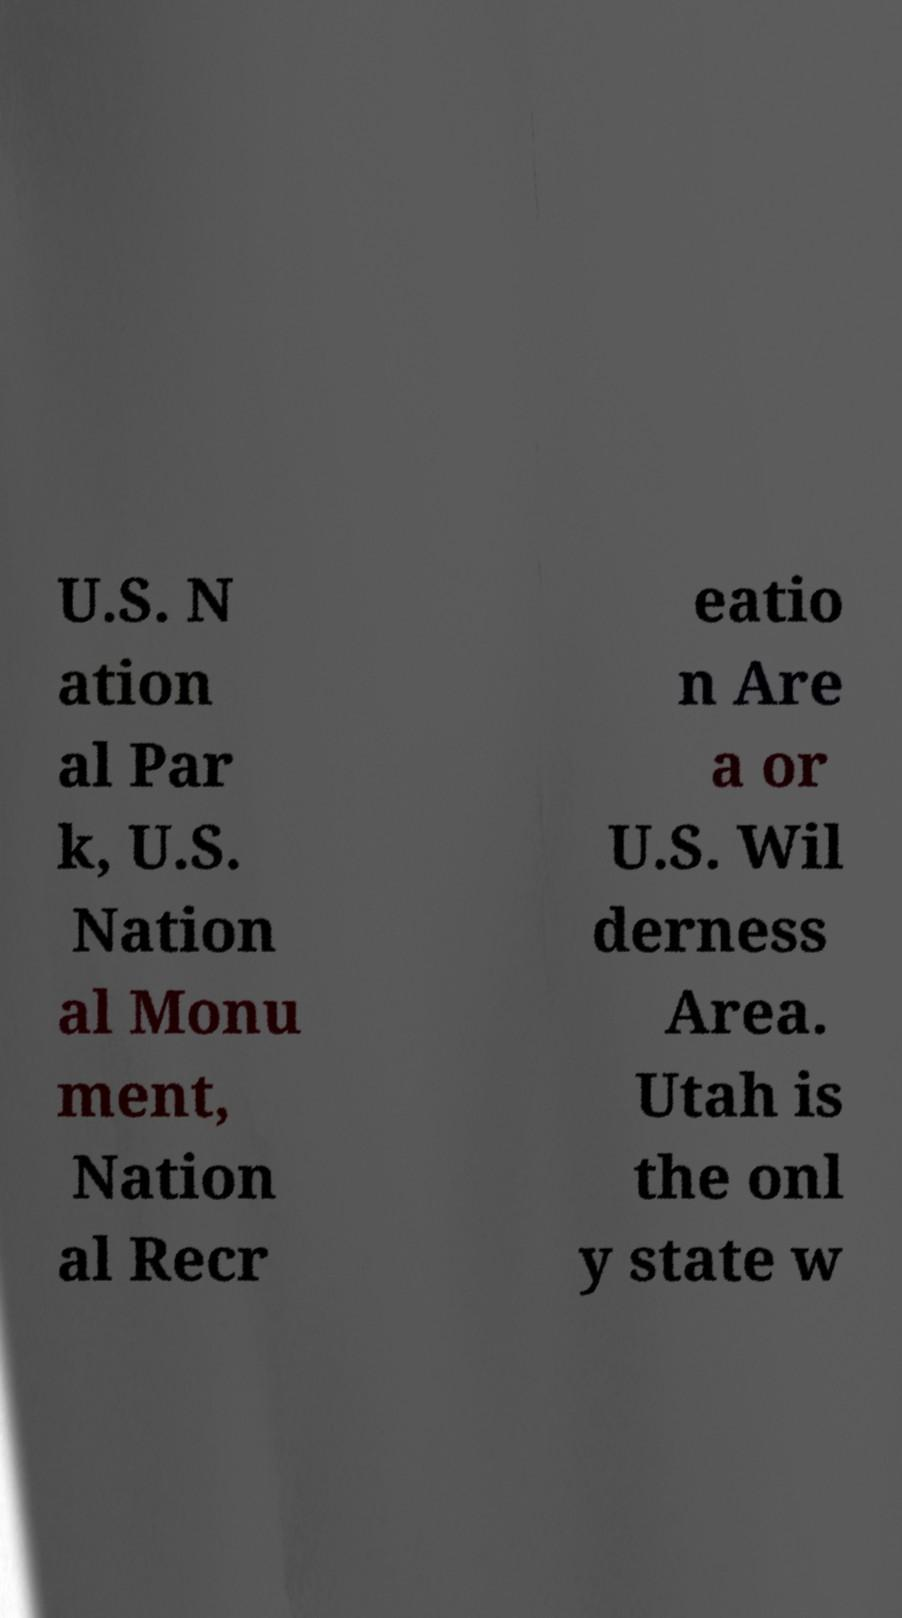Could you extract and type out the text from this image? U.S. N ation al Par k, U.S. Nation al Monu ment, Nation al Recr eatio n Are a or U.S. Wil derness Area. Utah is the onl y state w 